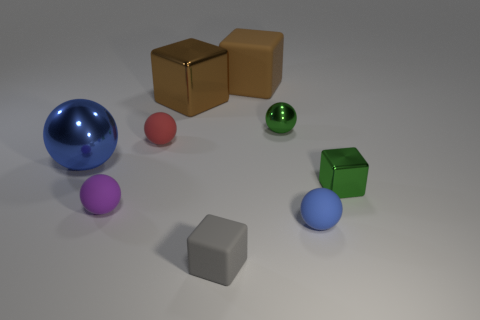Subtract all tiny green blocks. How many blocks are left? 3 Add 1 red matte things. How many objects exist? 10 Subtract all red spheres. How many spheres are left? 4 Subtract all blocks. How many objects are left? 5 Subtract 3 balls. How many balls are left? 2 Subtract all purple spheres. Subtract all yellow blocks. How many spheres are left? 4 Subtract all brown spheres. How many gray cubes are left? 1 Subtract all tiny gray cubes. Subtract all red rubber things. How many objects are left? 7 Add 1 small metallic blocks. How many small metallic blocks are left? 2 Add 8 tiny brown blocks. How many tiny brown blocks exist? 8 